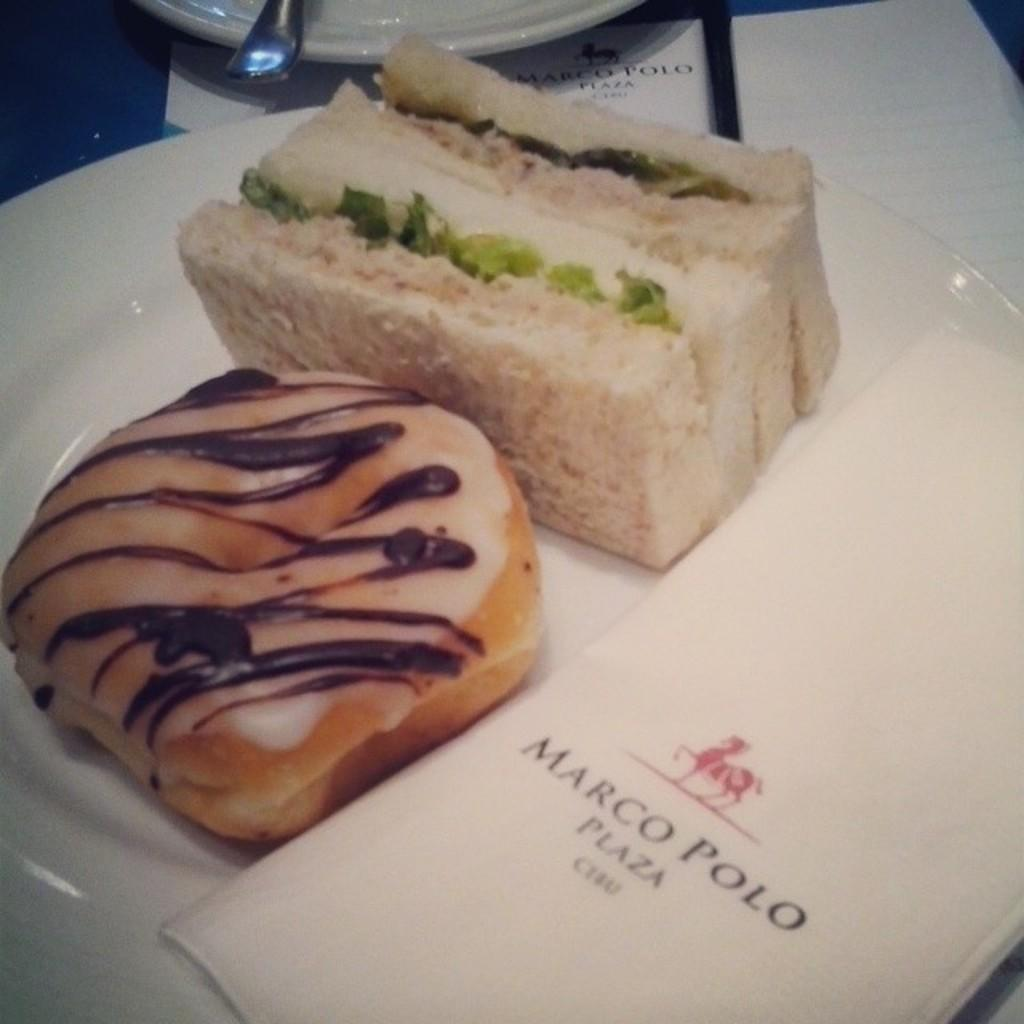What is on the plate in the image? There are food items on the plate in the image. Can you describe the colors of the food? The food has white, cream, and brown colors. What color is the plate? The plate is white. What type of bird can be seen feeling ashamed in the image? There are no birds or any indication of shame in the image; it only shows food items on a white plate. 